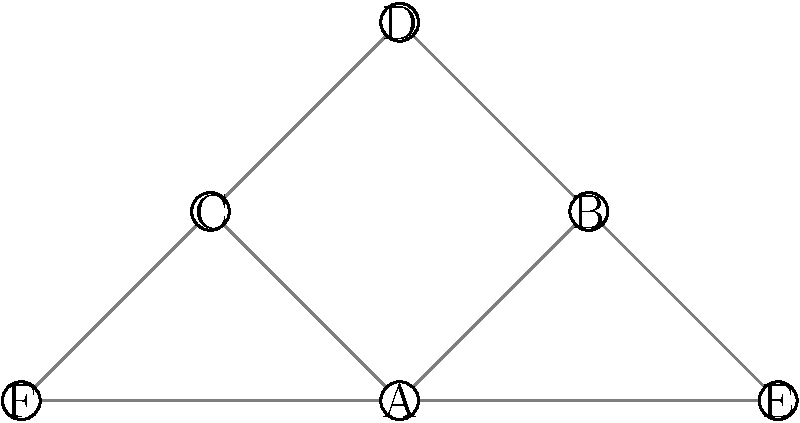In the network diagram above, which node is most likely to be the primary source of misinformation, assuming that misinformation spreads most efficiently through nodes with the highest number of connections? To determine the primary source of misinformation, we need to analyze the number of connections each node has:

1. Count the connections for each node:
   Node A: 4 connections
   Node B: 3 connections
   Node C: 3 connections
   Node D: 2 connections
   Node E: 2 connections
   Node F: 2 connections

2. Identify the node with the highest number of connections:
   Node A has the most connections (4), making it the most central node in the network.

3. Consider the implications:
   - A higher number of connections means more potential paths for information to spread.
   - Centrally located nodes can distribute information more quickly and widely.

4. Conclusion:
   Node A is most likely to be the primary source of misinformation due to its central position and highest number of connections, allowing for the most efficient spread of information (or misinformation) throughout the network.
Answer: Node A 